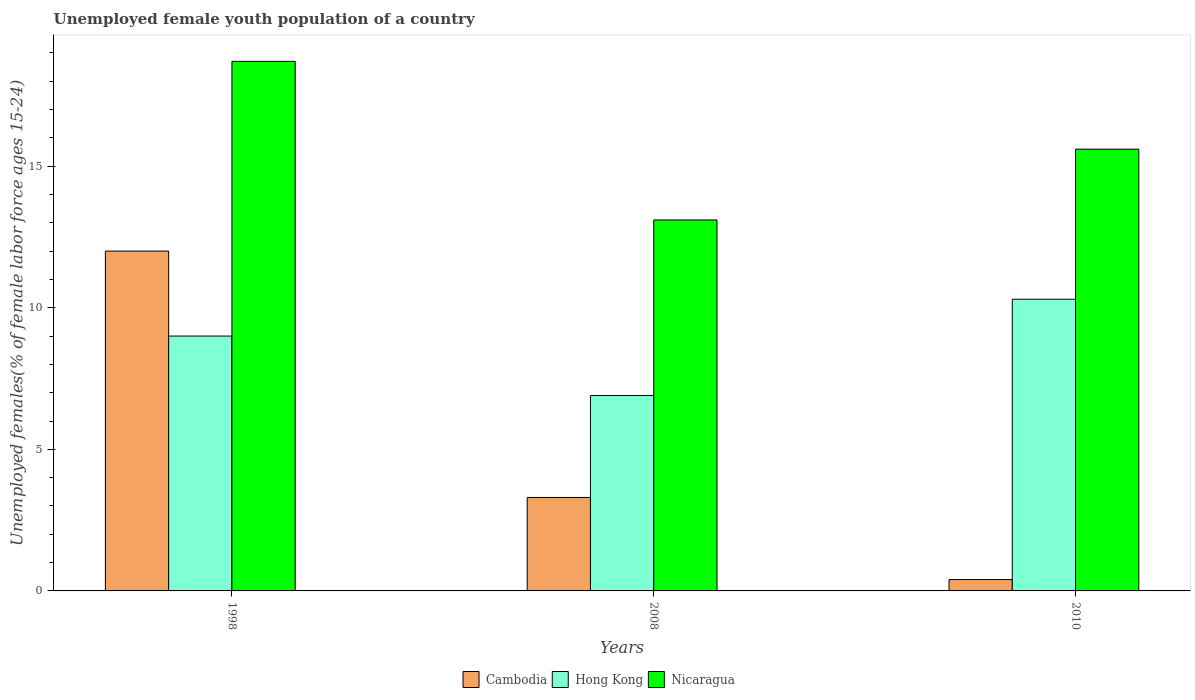How many different coloured bars are there?
Provide a succinct answer. 3. How many groups of bars are there?
Offer a very short reply. 3. Are the number of bars per tick equal to the number of legend labels?
Your answer should be very brief. Yes. Are the number of bars on each tick of the X-axis equal?
Offer a very short reply. Yes. How many bars are there on the 2nd tick from the left?
Your answer should be very brief. 3. What is the label of the 3rd group of bars from the left?
Give a very brief answer. 2010. What is the percentage of unemployed female youth population in Nicaragua in 2010?
Offer a very short reply. 15.6. Across all years, what is the maximum percentage of unemployed female youth population in Hong Kong?
Offer a terse response. 10.3. Across all years, what is the minimum percentage of unemployed female youth population in Hong Kong?
Your response must be concise. 6.9. What is the total percentage of unemployed female youth population in Nicaragua in the graph?
Make the answer very short. 47.4. What is the difference between the percentage of unemployed female youth population in Cambodia in 1998 and that in 2008?
Make the answer very short. 8.7. What is the difference between the percentage of unemployed female youth population in Nicaragua in 2008 and the percentage of unemployed female youth population in Cambodia in 2010?
Keep it short and to the point. 12.7. What is the average percentage of unemployed female youth population in Hong Kong per year?
Keep it short and to the point. 8.73. In the year 2008, what is the difference between the percentage of unemployed female youth population in Cambodia and percentage of unemployed female youth population in Hong Kong?
Your answer should be compact. -3.6. What is the ratio of the percentage of unemployed female youth population in Nicaragua in 1998 to that in 2010?
Provide a succinct answer. 1.2. Is the percentage of unemployed female youth population in Hong Kong in 1998 less than that in 2008?
Provide a short and direct response. No. What is the difference between the highest and the second highest percentage of unemployed female youth population in Hong Kong?
Offer a terse response. 1.3. What is the difference between the highest and the lowest percentage of unemployed female youth population in Nicaragua?
Keep it short and to the point. 5.6. In how many years, is the percentage of unemployed female youth population in Cambodia greater than the average percentage of unemployed female youth population in Cambodia taken over all years?
Keep it short and to the point. 1. Is the sum of the percentage of unemployed female youth population in Nicaragua in 2008 and 2010 greater than the maximum percentage of unemployed female youth population in Hong Kong across all years?
Your response must be concise. Yes. What does the 1st bar from the left in 1998 represents?
Your answer should be compact. Cambodia. What does the 3rd bar from the right in 2008 represents?
Offer a very short reply. Cambodia. How many bars are there?
Offer a terse response. 9. What is the difference between two consecutive major ticks on the Y-axis?
Your answer should be compact. 5. Does the graph contain grids?
Make the answer very short. No. How many legend labels are there?
Your answer should be very brief. 3. What is the title of the graph?
Offer a very short reply. Unemployed female youth population of a country. What is the label or title of the Y-axis?
Provide a succinct answer. Unemployed females(% of female labor force ages 15-24). What is the Unemployed females(% of female labor force ages 15-24) of Cambodia in 1998?
Provide a succinct answer. 12. What is the Unemployed females(% of female labor force ages 15-24) of Hong Kong in 1998?
Offer a terse response. 9. What is the Unemployed females(% of female labor force ages 15-24) in Nicaragua in 1998?
Keep it short and to the point. 18.7. What is the Unemployed females(% of female labor force ages 15-24) of Cambodia in 2008?
Your answer should be compact. 3.3. What is the Unemployed females(% of female labor force ages 15-24) in Hong Kong in 2008?
Offer a terse response. 6.9. What is the Unemployed females(% of female labor force ages 15-24) of Nicaragua in 2008?
Your response must be concise. 13.1. What is the Unemployed females(% of female labor force ages 15-24) of Cambodia in 2010?
Your answer should be compact. 0.4. What is the Unemployed females(% of female labor force ages 15-24) in Hong Kong in 2010?
Provide a succinct answer. 10.3. What is the Unemployed females(% of female labor force ages 15-24) of Nicaragua in 2010?
Your answer should be very brief. 15.6. Across all years, what is the maximum Unemployed females(% of female labor force ages 15-24) of Hong Kong?
Your response must be concise. 10.3. Across all years, what is the maximum Unemployed females(% of female labor force ages 15-24) of Nicaragua?
Ensure brevity in your answer.  18.7. Across all years, what is the minimum Unemployed females(% of female labor force ages 15-24) of Cambodia?
Offer a very short reply. 0.4. Across all years, what is the minimum Unemployed females(% of female labor force ages 15-24) in Hong Kong?
Your answer should be very brief. 6.9. Across all years, what is the minimum Unemployed females(% of female labor force ages 15-24) in Nicaragua?
Ensure brevity in your answer.  13.1. What is the total Unemployed females(% of female labor force ages 15-24) in Hong Kong in the graph?
Ensure brevity in your answer.  26.2. What is the total Unemployed females(% of female labor force ages 15-24) of Nicaragua in the graph?
Give a very brief answer. 47.4. What is the difference between the Unemployed females(% of female labor force ages 15-24) in Cambodia in 1998 and that in 2008?
Give a very brief answer. 8.7. What is the difference between the Unemployed females(% of female labor force ages 15-24) of Hong Kong in 1998 and that in 2008?
Your answer should be compact. 2.1. What is the difference between the Unemployed females(% of female labor force ages 15-24) of Hong Kong in 1998 and that in 2010?
Your response must be concise. -1.3. What is the difference between the Unemployed females(% of female labor force ages 15-24) in Nicaragua in 1998 and that in 2010?
Provide a succinct answer. 3.1. What is the difference between the Unemployed females(% of female labor force ages 15-24) in Cambodia in 1998 and the Unemployed females(% of female labor force ages 15-24) in Nicaragua in 2008?
Make the answer very short. -1.1. What is the difference between the Unemployed females(% of female labor force ages 15-24) of Hong Kong in 1998 and the Unemployed females(% of female labor force ages 15-24) of Nicaragua in 2008?
Ensure brevity in your answer.  -4.1. What is the difference between the Unemployed females(% of female labor force ages 15-24) of Cambodia in 1998 and the Unemployed females(% of female labor force ages 15-24) of Hong Kong in 2010?
Keep it short and to the point. 1.7. What is the difference between the Unemployed females(% of female labor force ages 15-24) of Cambodia in 1998 and the Unemployed females(% of female labor force ages 15-24) of Nicaragua in 2010?
Ensure brevity in your answer.  -3.6. What is the difference between the Unemployed females(% of female labor force ages 15-24) of Hong Kong in 1998 and the Unemployed females(% of female labor force ages 15-24) of Nicaragua in 2010?
Your response must be concise. -6.6. What is the difference between the Unemployed females(% of female labor force ages 15-24) of Cambodia in 2008 and the Unemployed females(% of female labor force ages 15-24) of Nicaragua in 2010?
Offer a terse response. -12.3. What is the difference between the Unemployed females(% of female labor force ages 15-24) in Hong Kong in 2008 and the Unemployed females(% of female labor force ages 15-24) in Nicaragua in 2010?
Your answer should be compact. -8.7. What is the average Unemployed females(% of female labor force ages 15-24) of Cambodia per year?
Your answer should be very brief. 5.23. What is the average Unemployed females(% of female labor force ages 15-24) in Hong Kong per year?
Your answer should be very brief. 8.73. In the year 1998, what is the difference between the Unemployed females(% of female labor force ages 15-24) in Cambodia and Unemployed females(% of female labor force ages 15-24) in Hong Kong?
Make the answer very short. 3. In the year 1998, what is the difference between the Unemployed females(% of female labor force ages 15-24) in Cambodia and Unemployed females(% of female labor force ages 15-24) in Nicaragua?
Provide a short and direct response. -6.7. In the year 2008, what is the difference between the Unemployed females(% of female labor force ages 15-24) in Cambodia and Unemployed females(% of female labor force ages 15-24) in Nicaragua?
Your answer should be very brief. -9.8. In the year 2010, what is the difference between the Unemployed females(% of female labor force ages 15-24) of Cambodia and Unemployed females(% of female labor force ages 15-24) of Nicaragua?
Offer a very short reply. -15.2. In the year 2010, what is the difference between the Unemployed females(% of female labor force ages 15-24) of Hong Kong and Unemployed females(% of female labor force ages 15-24) of Nicaragua?
Provide a succinct answer. -5.3. What is the ratio of the Unemployed females(% of female labor force ages 15-24) of Cambodia in 1998 to that in 2008?
Your answer should be compact. 3.64. What is the ratio of the Unemployed females(% of female labor force ages 15-24) of Hong Kong in 1998 to that in 2008?
Offer a terse response. 1.3. What is the ratio of the Unemployed females(% of female labor force ages 15-24) of Nicaragua in 1998 to that in 2008?
Ensure brevity in your answer.  1.43. What is the ratio of the Unemployed females(% of female labor force ages 15-24) of Cambodia in 1998 to that in 2010?
Offer a terse response. 30. What is the ratio of the Unemployed females(% of female labor force ages 15-24) of Hong Kong in 1998 to that in 2010?
Provide a short and direct response. 0.87. What is the ratio of the Unemployed females(% of female labor force ages 15-24) of Nicaragua in 1998 to that in 2010?
Give a very brief answer. 1.2. What is the ratio of the Unemployed females(% of female labor force ages 15-24) in Cambodia in 2008 to that in 2010?
Your response must be concise. 8.25. What is the ratio of the Unemployed females(% of female labor force ages 15-24) of Hong Kong in 2008 to that in 2010?
Offer a terse response. 0.67. What is the ratio of the Unemployed females(% of female labor force ages 15-24) of Nicaragua in 2008 to that in 2010?
Provide a short and direct response. 0.84. What is the difference between the highest and the second highest Unemployed females(% of female labor force ages 15-24) of Hong Kong?
Offer a very short reply. 1.3. What is the difference between the highest and the second highest Unemployed females(% of female labor force ages 15-24) of Nicaragua?
Keep it short and to the point. 3.1. What is the difference between the highest and the lowest Unemployed females(% of female labor force ages 15-24) of Cambodia?
Make the answer very short. 11.6. What is the difference between the highest and the lowest Unemployed females(% of female labor force ages 15-24) of Hong Kong?
Give a very brief answer. 3.4. 